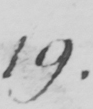Please transcribe the handwritten text in this image. 19 . 